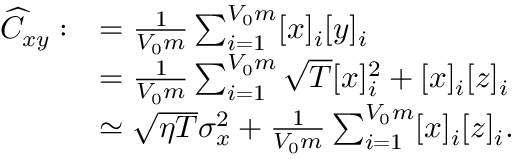<formula> <loc_0><loc_0><loc_500><loc_500>\begin{array} { r l } { \widehat { C } _ { x y } \colon } & { = \frac { 1 } { V _ { 0 } m } \sum _ { i = 1 } ^ { V _ { 0 } m } [ x ] _ { i } [ y ] _ { i } } \\ & { = \frac { 1 } { V _ { 0 } m } \sum _ { i = 1 } ^ { V _ { 0 } m } \sqrt { T } [ x ] _ { i } ^ { 2 } + [ x ] _ { i } [ z ] _ { i } } \\ & { \simeq \sqrt { \eta T } \sigma _ { x } ^ { 2 } + \frac { 1 } { V _ { 0 } m } \sum _ { i = 1 } ^ { V _ { 0 } m } [ x ] _ { i } [ z ] _ { i } . } \end{array}</formula> 